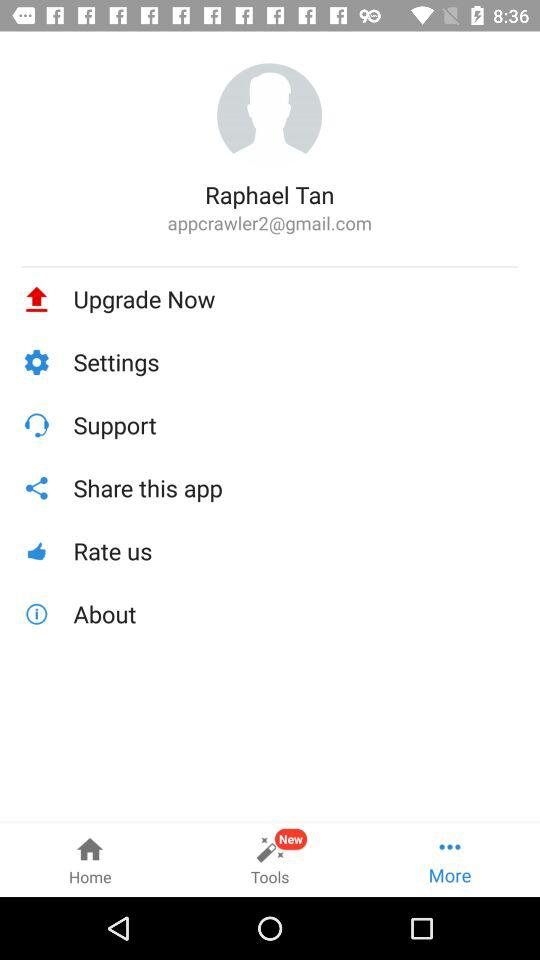What is the email ID of Raphael? The email address is "appcrawler2@gmail.com". 